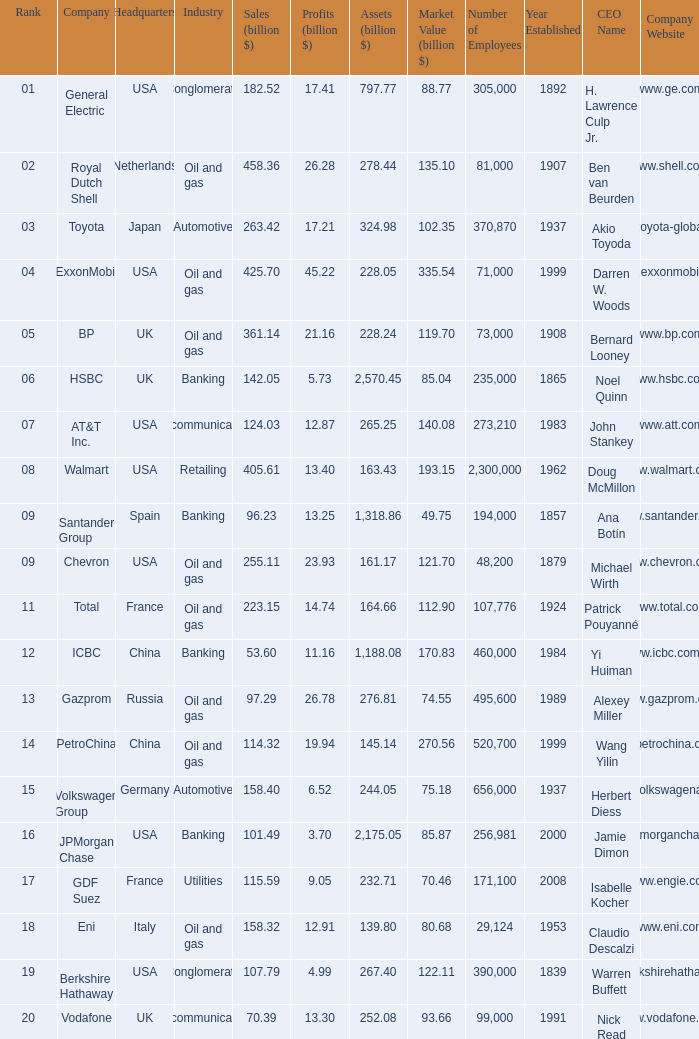Name the highest Profits (billion $) which has a Company of walmart? 13.4. 